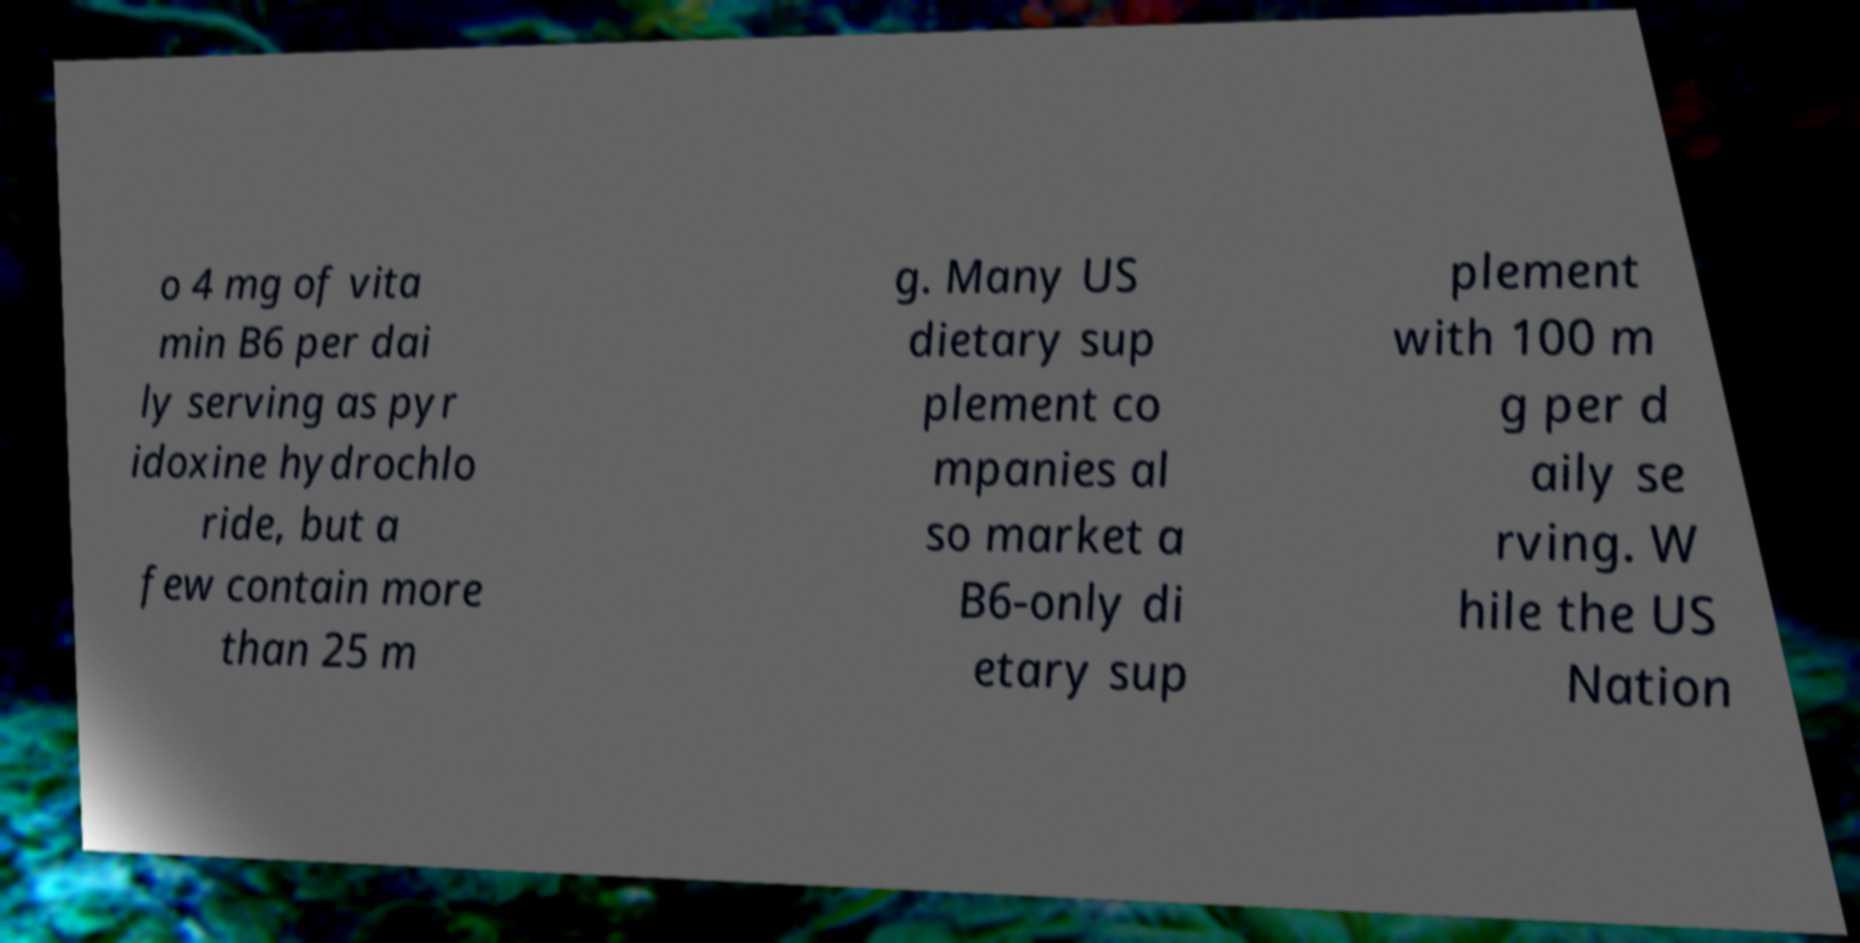There's text embedded in this image that I need extracted. Can you transcribe it verbatim? o 4 mg of vita min B6 per dai ly serving as pyr idoxine hydrochlo ride, but a few contain more than 25 m g. Many US dietary sup plement co mpanies al so market a B6-only di etary sup plement with 100 m g per d aily se rving. W hile the US Nation 